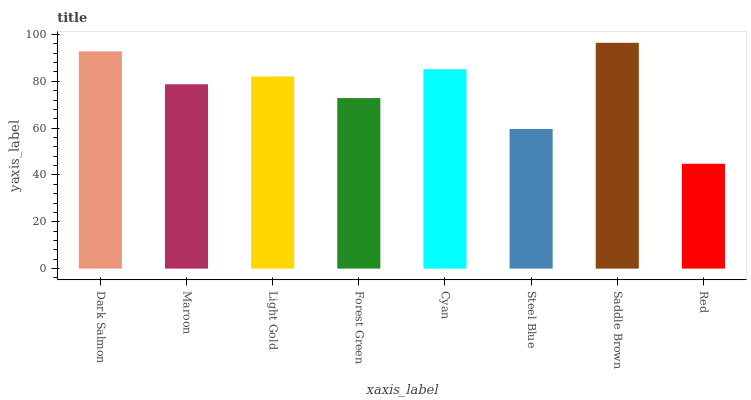Is Maroon the minimum?
Answer yes or no. No. Is Maroon the maximum?
Answer yes or no. No. Is Dark Salmon greater than Maroon?
Answer yes or no. Yes. Is Maroon less than Dark Salmon?
Answer yes or no. Yes. Is Maroon greater than Dark Salmon?
Answer yes or no. No. Is Dark Salmon less than Maroon?
Answer yes or no. No. Is Light Gold the high median?
Answer yes or no. Yes. Is Maroon the low median?
Answer yes or no. Yes. Is Dark Salmon the high median?
Answer yes or no. No. Is Red the low median?
Answer yes or no. No. 